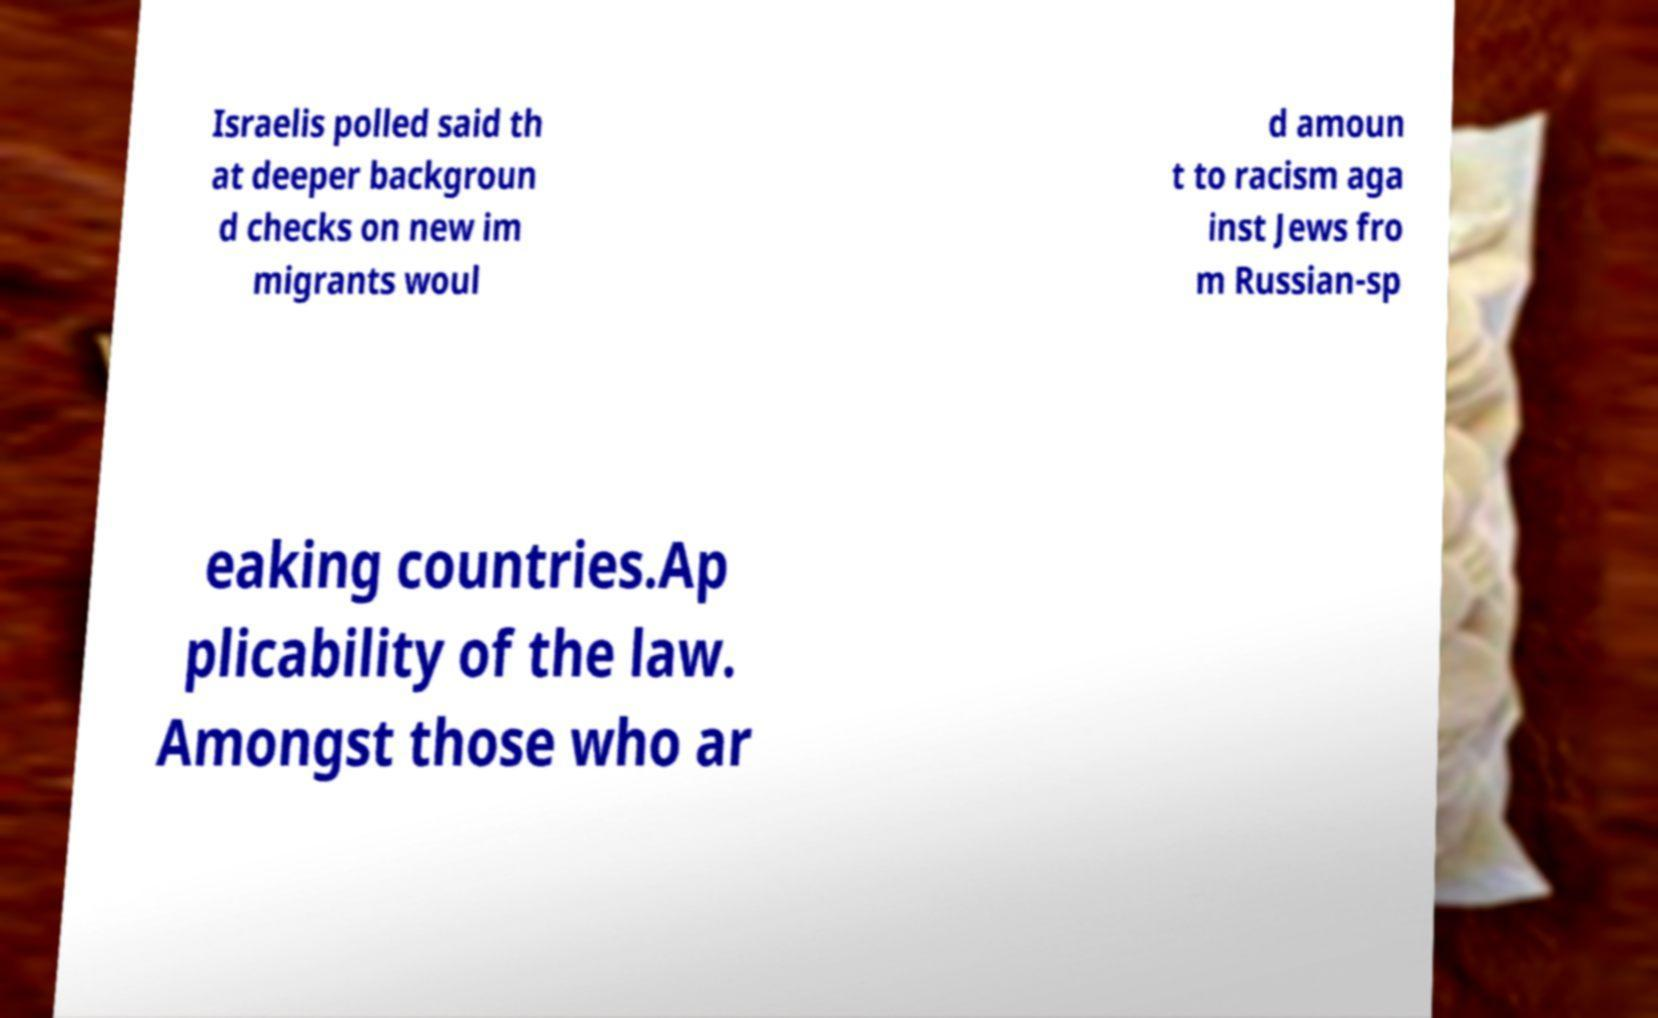Could you extract and type out the text from this image? Israelis polled said th at deeper backgroun d checks on new im migrants woul d amoun t to racism aga inst Jews fro m Russian-sp eaking countries.Ap plicability of the law. Amongst those who ar 